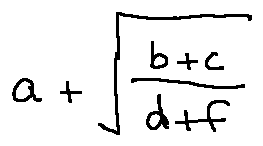<formula> <loc_0><loc_0><loc_500><loc_500>a + \sqrt { \frac { b + c } { d + f } }</formula> 